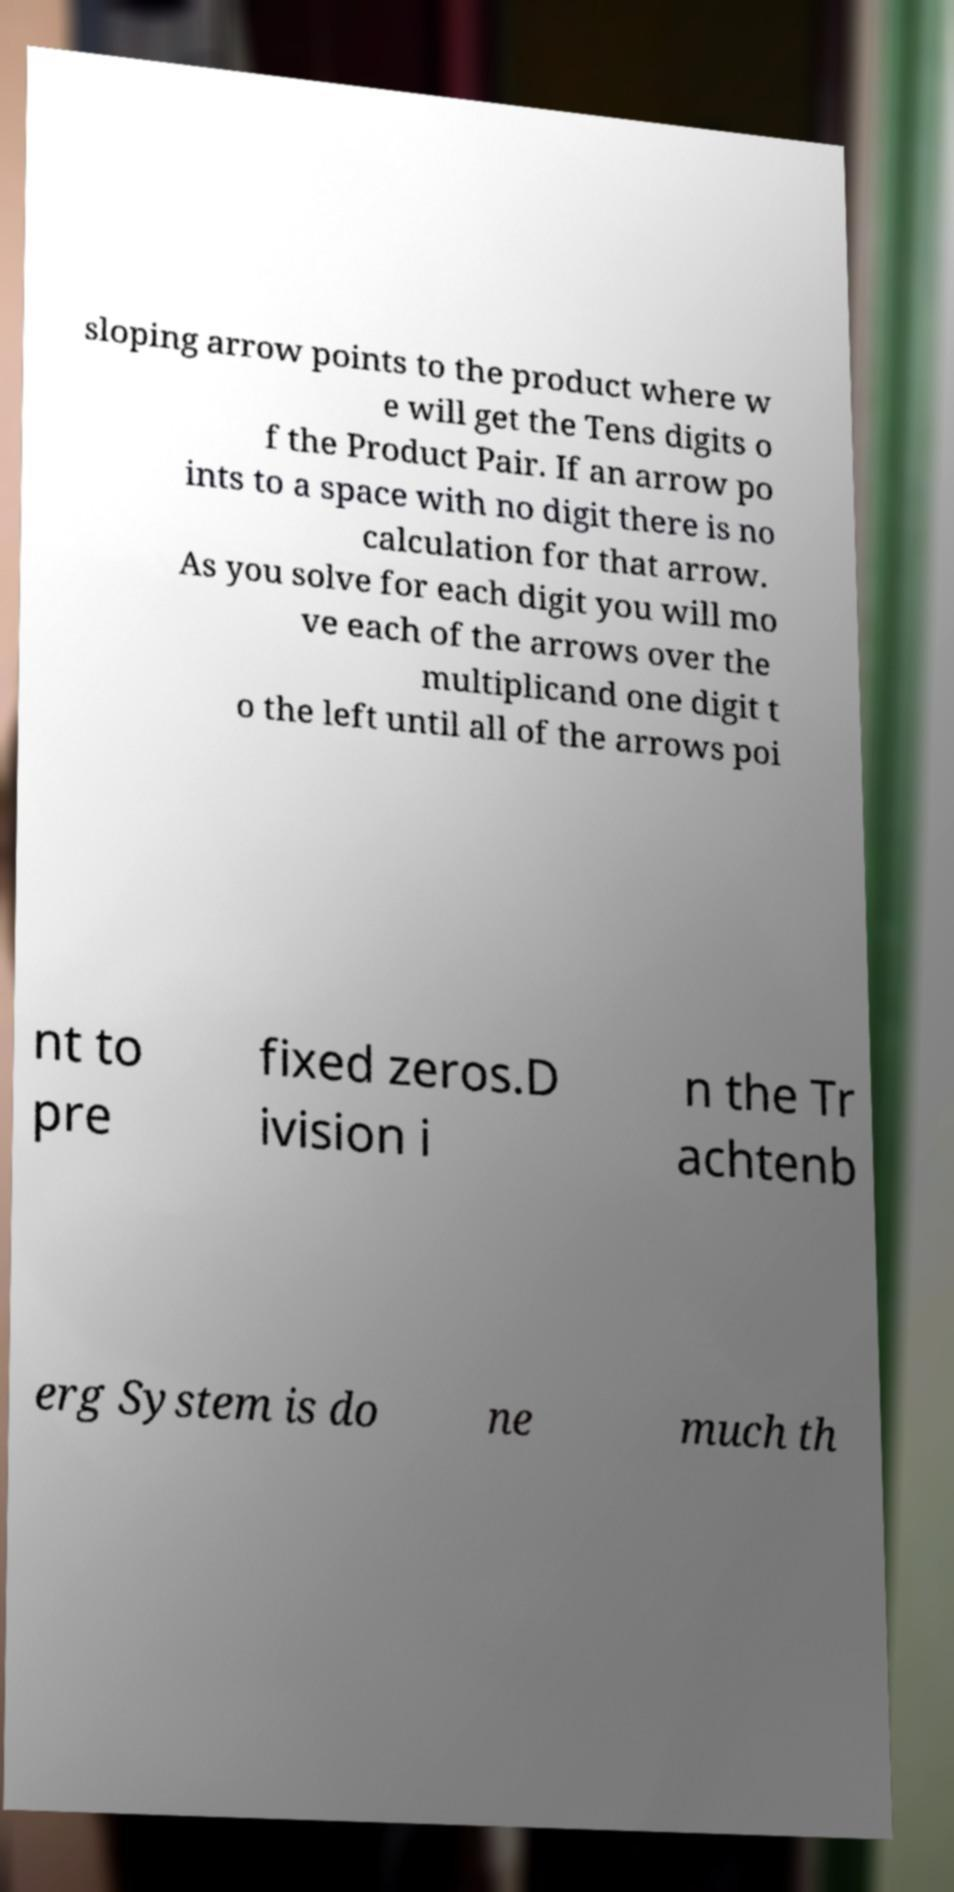Could you extract and type out the text from this image? sloping arrow points to the product where w e will get the Tens digits o f the Product Pair. If an arrow po ints to a space with no digit there is no calculation for that arrow. As you solve for each digit you will mo ve each of the arrows over the multiplicand one digit t o the left until all of the arrows poi nt to pre fixed zeros.D ivision i n the Tr achtenb erg System is do ne much th 